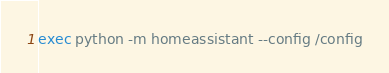Convert code to text. <code><loc_0><loc_0><loc_500><loc_500><_Bash_>exec python -m homeassistant --config /config</code> 